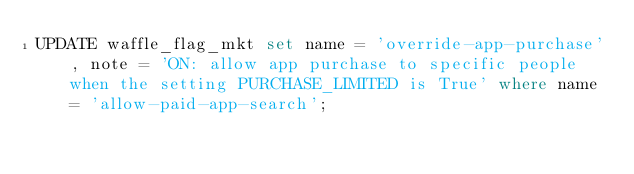Convert code to text. <code><loc_0><loc_0><loc_500><loc_500><_SQL_>UPDATE waffle_flag_mkt set name = 'override-app-purchase', note = 'ON: allow app purchase to specific people when the setting PURCHASE_LIMITED is True' where name = 'allow-paid-app-search';
</code> 